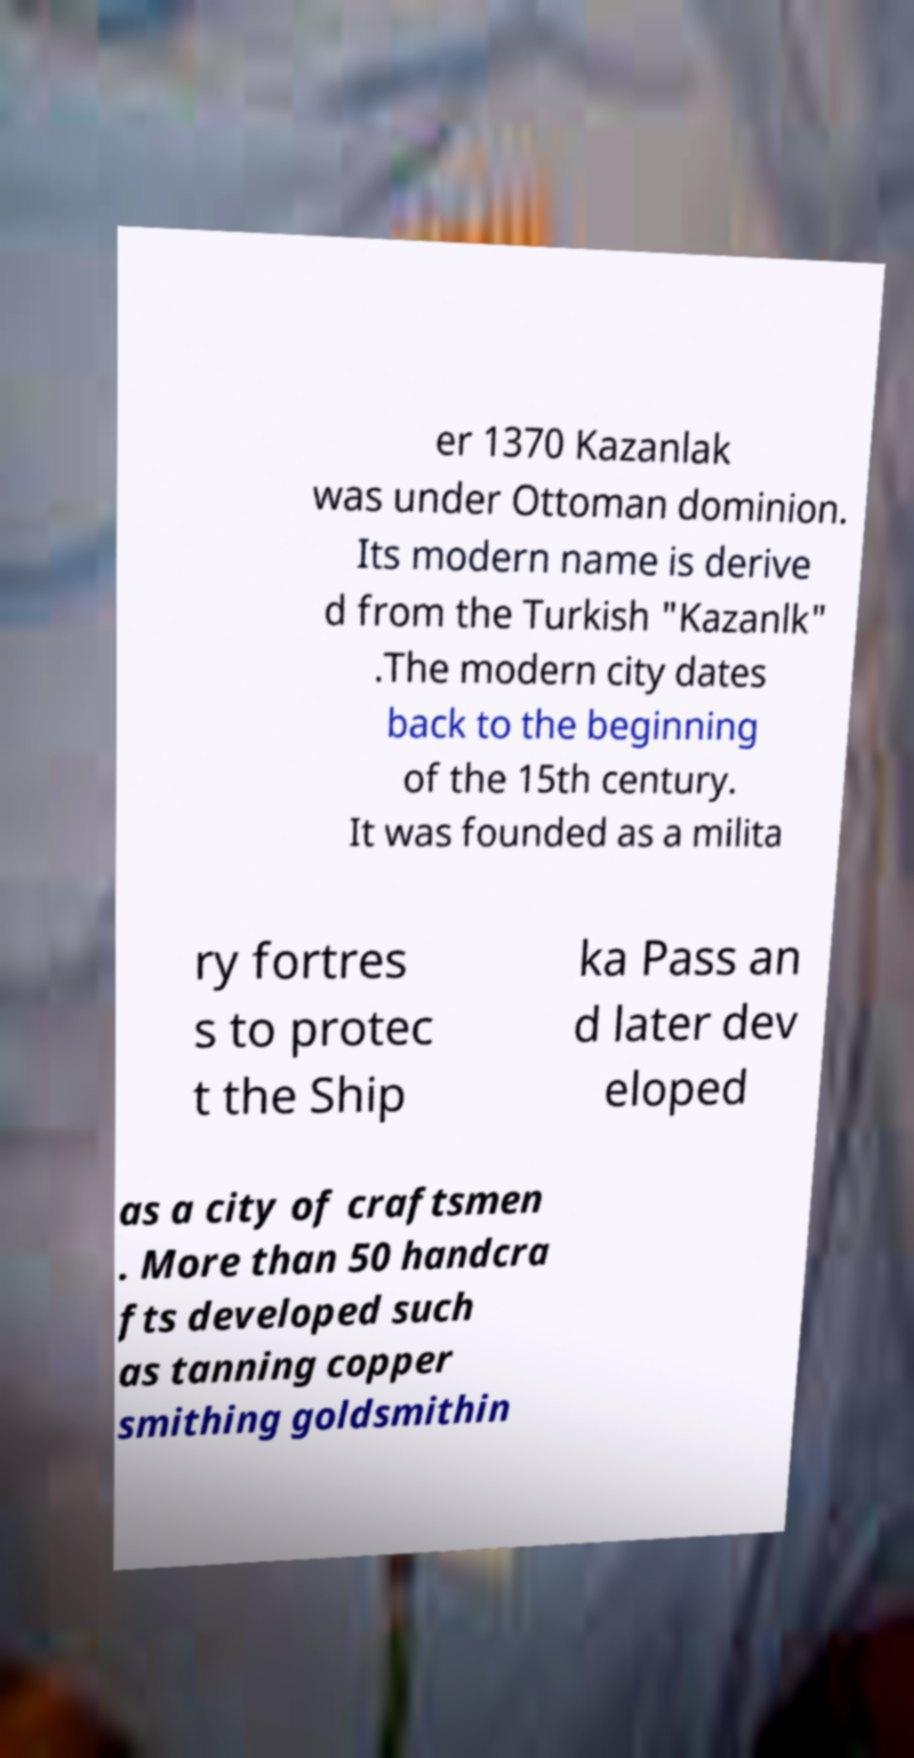I need the written content from this picture converted into text. Can you do that? er 1370 Kazanlak was under Ottoman dominion. Its modern name is derive d from the Turkish "Kazanlk" .The modern city dates back to the beginning of the 15th century. It was founded as a milita ry fortres s to protec t the Ship ka Pass an d later dev eloped as a city of craftsmen . More than 50 handcra fts developed such as tanning copper smithing goldsmithin 